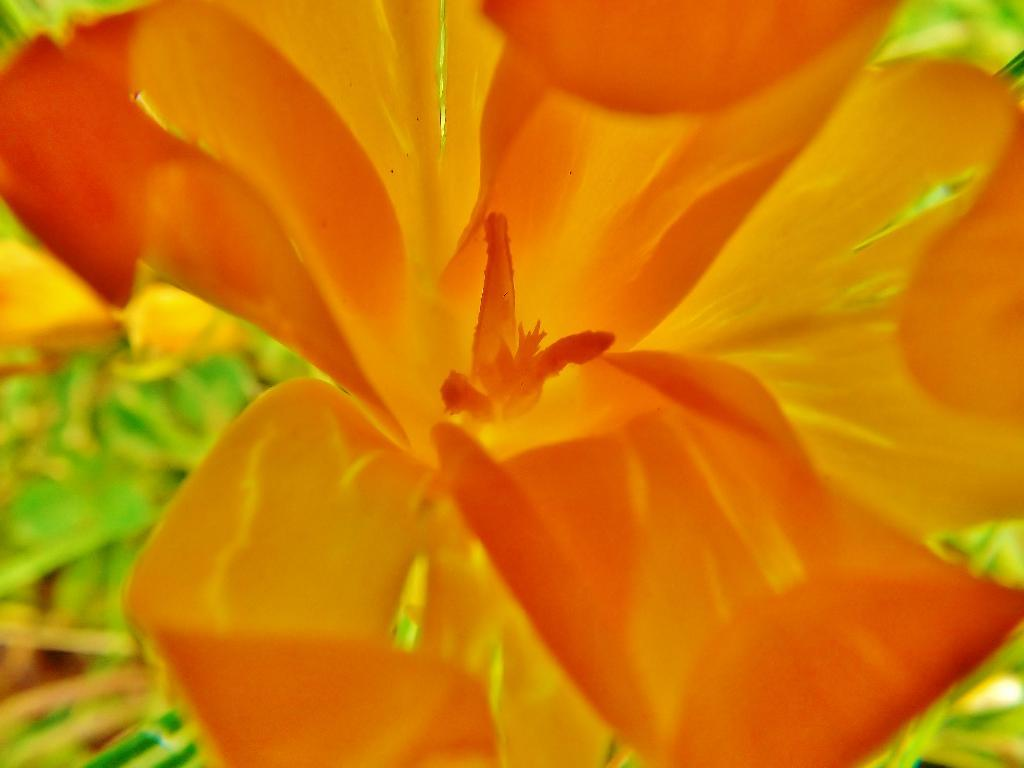What type of flower is present in the image? There is an orange color flower in the image. Can you describe the background of the image? The background of the image is blurred. What type of iron can be seen in the image? There is no iron present in the image. What store is visible in the image? There is no store present in the image. What selection of items can be seen in the image? There is no selection of items present in the image; it only features an orange color flower and a blurred background. 